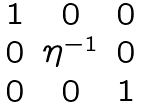<formula> <loc_0><loc_0><loc_500><loc_500>\begin{matrix} 1 & 0 & 0 \\ 0 & \eta ^ { - 1 } & 0 \\ 0 & 0 & 1 \end{matrix}</formula> 